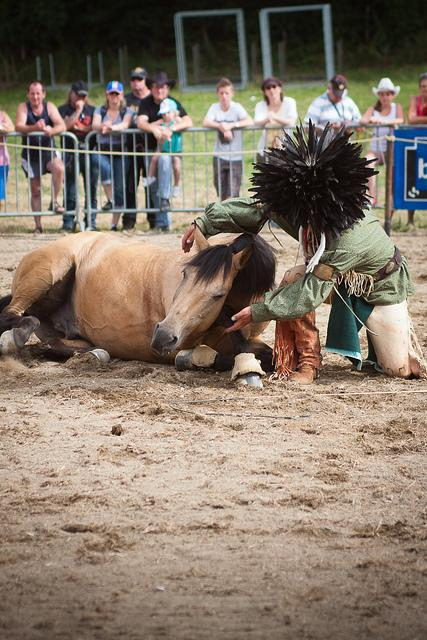Most horses that are used for racing are ridden by professional riders called as? Please explain your reasoning. jockeys. Horses that are ridden for racing are ridden by professionals called jockeys. 